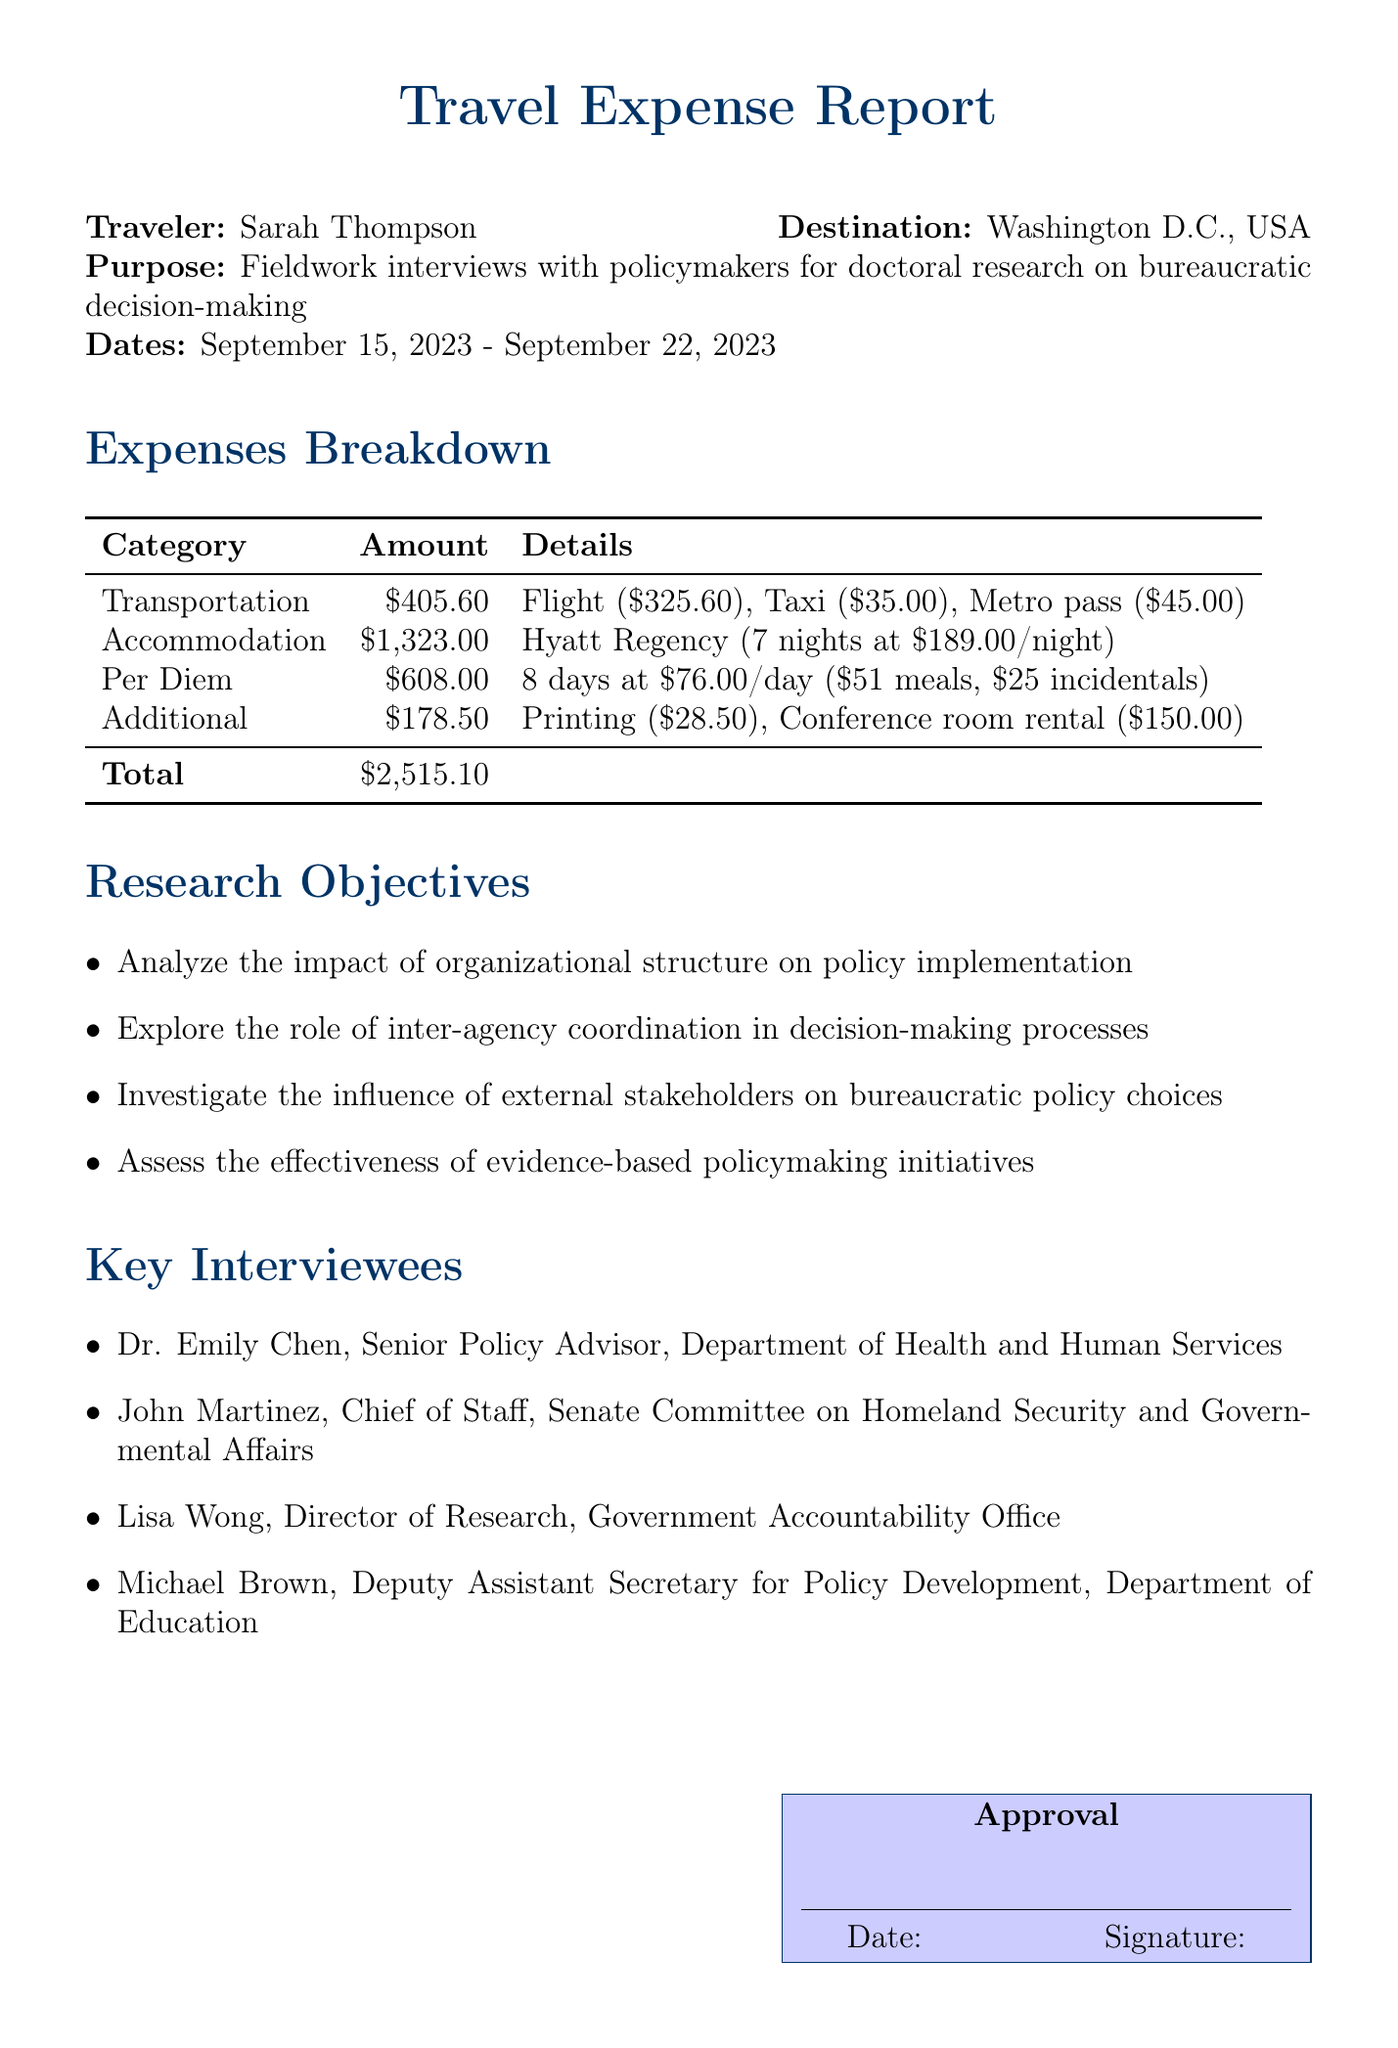What is the name of the traveler? The traveler is identified in the document as Sarah Thompson.
Answer: Sarah Thompson What is the total cost for accommodation? The document states that the cost for accommodation at Hyatt Regency for 7 nights is 1323.00.
Answer: 1323.00 What was the cost of the flight? The flight cost listed in the transportation section is specified as 325.60.
Answer: 325.60 How many interviewees were there? The document lists four key interviewees for the fieldwork interviews.
Answer: 4 What are the daily per diem rates? The per diem daily rate outlined in the document is 76.00.
Answer: 76.00 What total amount was spent on transportation? The transportation costs outlined add up to a total of 405.60, which includes flight, taxi, and metro.
Answer: 405.60 What type of research objectives were included in the document? The objectives focus on organizational structure impact, inter-agency coordination, stakeholder influence, and evidence-based policymaking.
Answer: Organizational structure impact, inter-agency coordination, stakeholder influence, evidence-based policymaking How many nights did the traveler stay? The traveler stayed for 7 nights as stated in the accommodation section.
Answer: 7 What was the total amount of additional expenses? The document mentions that the additional expenses totaled 178.50.
Answer: 178.50 What is the purpose of Sarah Thompson's travel? The purpose stated is to conduct fieldwork interviews with policymakers for her doctoral research on bureaucratic decision-making.
Answer: Fieldwork interviews with policymakers for doctoral research on bureaucratic decision-making 